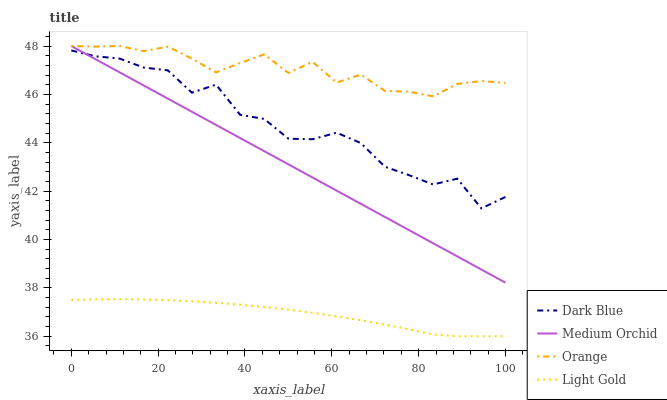Does Light Gold have the minimum area under the curve?
Answer yes or no. Yes. Does Orange have the maximum area under the curve?
Answer yes or no. Yes. Does Dark Blue have the minimum area under the curve?
Answer yes or no. No. Does Dark Blue have the maximum area under the curve?
Answer yes or no. No. Is Medium Orchid the smoothest?
Answer yes or no. Yes. Is Dark Blue the roughest?
Answer yes or no. Yes. Is Dark Blue the smoothest?
Answer yes or no. No. Is Medium Orchid the roughest?
Answer yes or no. No. Does Light Gold have the lowest value?
Answer yes or no. Yes. Does Dark Blue have the lowest value?
Answer yes or no. No. Does Medium Orchid have the highest value?
Answer yes or no. Yes. Does Dark Blue have the highest value?
Answer yes or no. No. Is Dark Blue less than Orange?
Answer yes or no. Yes. Is Orange greater than Light Gold?
Answer yes or no. Yes. Does Dark Blue intersect Medium Orchid?
Answer yes or no. Yes. Is Dark Blue less than Medium Orchid?
Answer yes or no. No. Is Dark Blue greater than Medium Orchid?
Answer yes or no. No. Does Dark Blue intersect Orange?
Answer yes or no. No. 